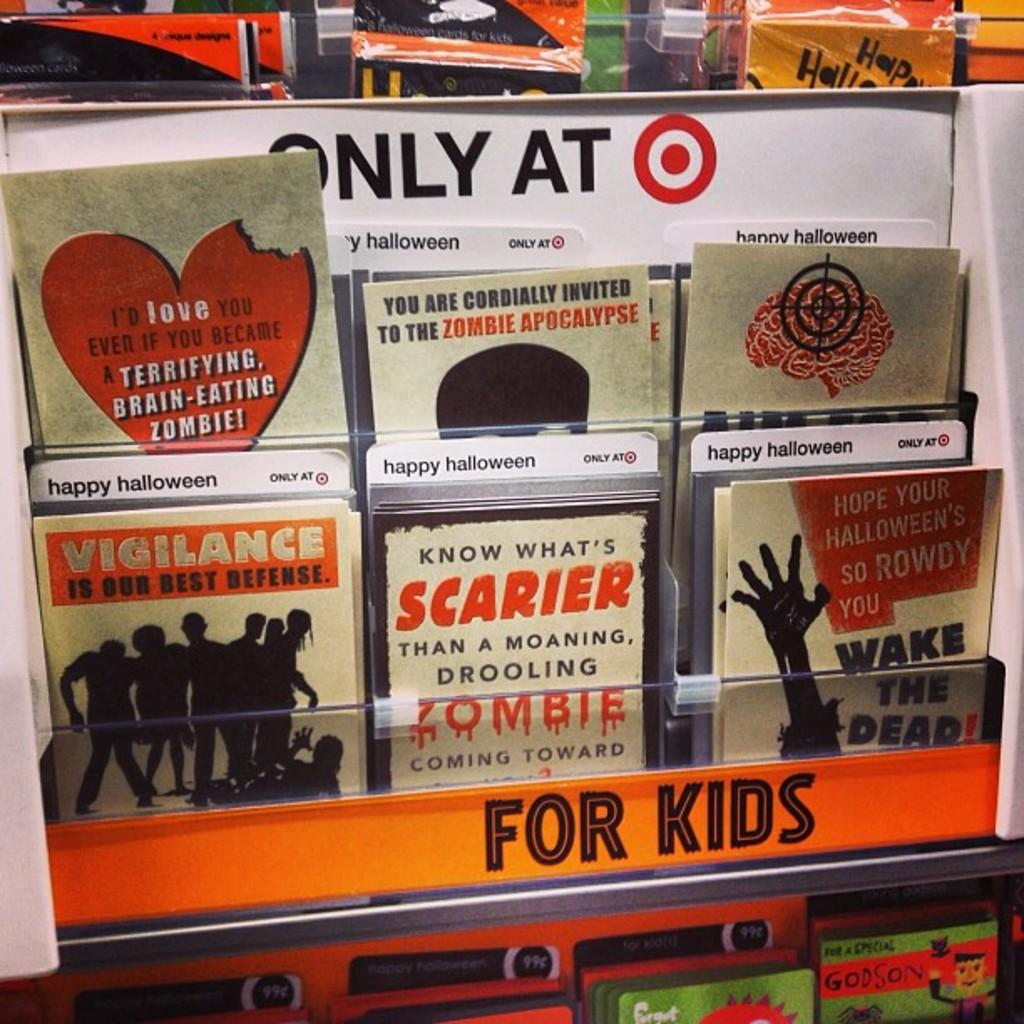Provide a one-sentence caption for the provided image. A series of Halloween cards for kids at Target. 